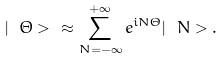Convert formula to latex. <formula><loc_0><loc_0><loc_500><loc_500>| \ \Theta > \ \approx \sum _ { N = - \infty } ^ { + \infty } e ^ { i N \Theta } | \ N > .</formula> 